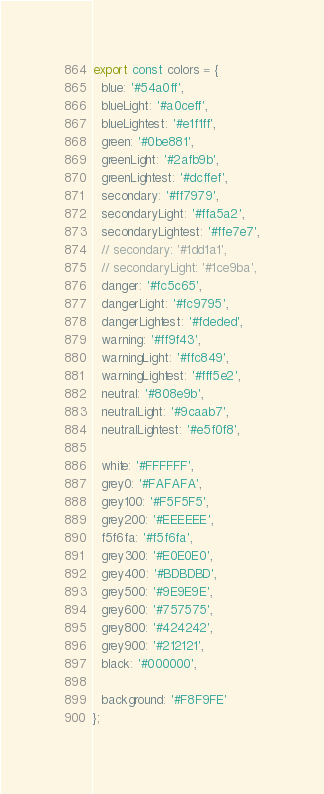<code> <loc_0><loc_0><loc_500><loc_500><_TypeScript_>export const colors = {
  blue: '#54a0ff',
  blueLight: '#a0ceff',
  blueLightest: '#e1f1ff',
  green: '#0be881',
  greenLight: '#2afb9b',
  greenLightest: '#dcffef',
  secondary: '#ff7979',
  secondaryLight: '#ffa5a2',
  secondaryLightest: '#ffe7e7',
  // secondary: '#1dd1a1',
  // secondaryLight: '#1ce9ba',
  danger: '#fc5c65',
  dangerLight: '#fc9795',
  dangerLightest: '#fdeded',
  warning: '#ff9f43',
  warningLight: '#ffc849',
  warningLightest: '#fff5e2',
  neutral: '#808e9b',
  neutralLight: '#9caab7',
  neutralLightest: '#e5f0f8',

  white: '#FFFFFF',
  grey0: '#FAFAFA',
  grey100: '#F5F5F5',
  grey200: '#EEEEEE',
  f5f6fa: '#f5f6fa',
  grey300: '#E0E0E0',
  grey400: '#BDBDBD',
  grey500: '#9E9E9E',
  grey600: '#757575',
  grey800: '#424242',
  grey900: '#212121',
  black: '#000000',

  background: '#F8F9FE'
};
</code> 